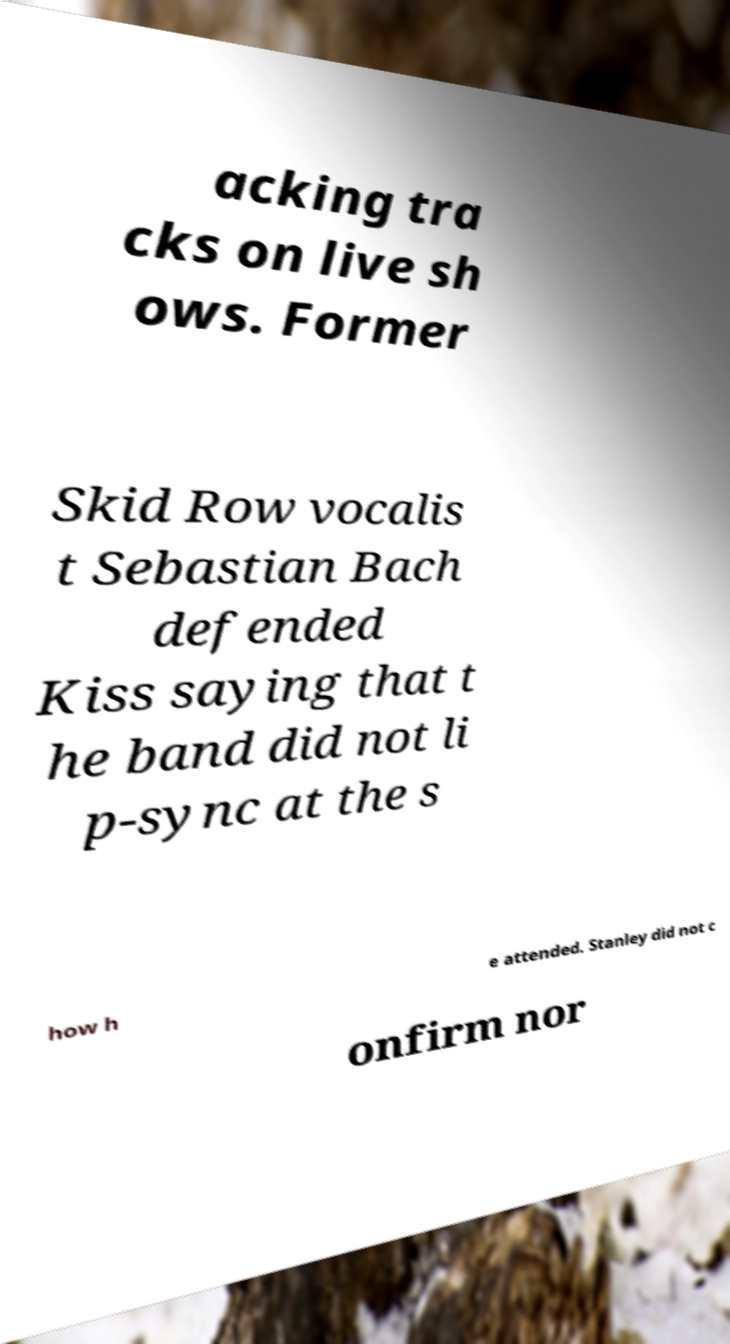There's text embedded in this image that I need extracted. Can you transcribe it verbatim? acking tra cks on live sh ows. Former Skid Row vocalis t Sebastian Bach defended Kiss saying that t he band did not li p-sync at the s how h e attended. Stanley did not c onfirm nor 